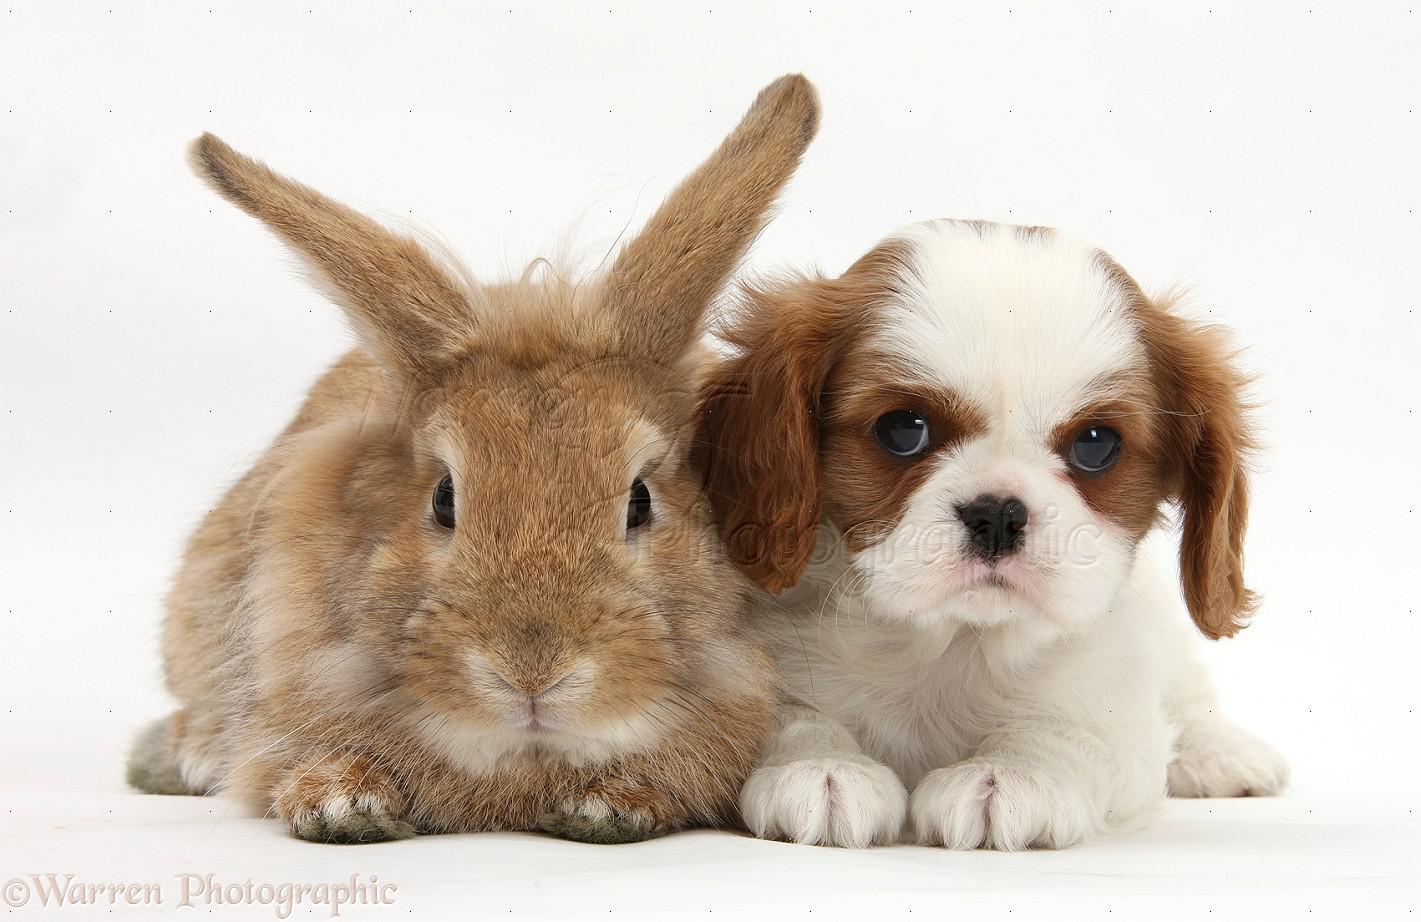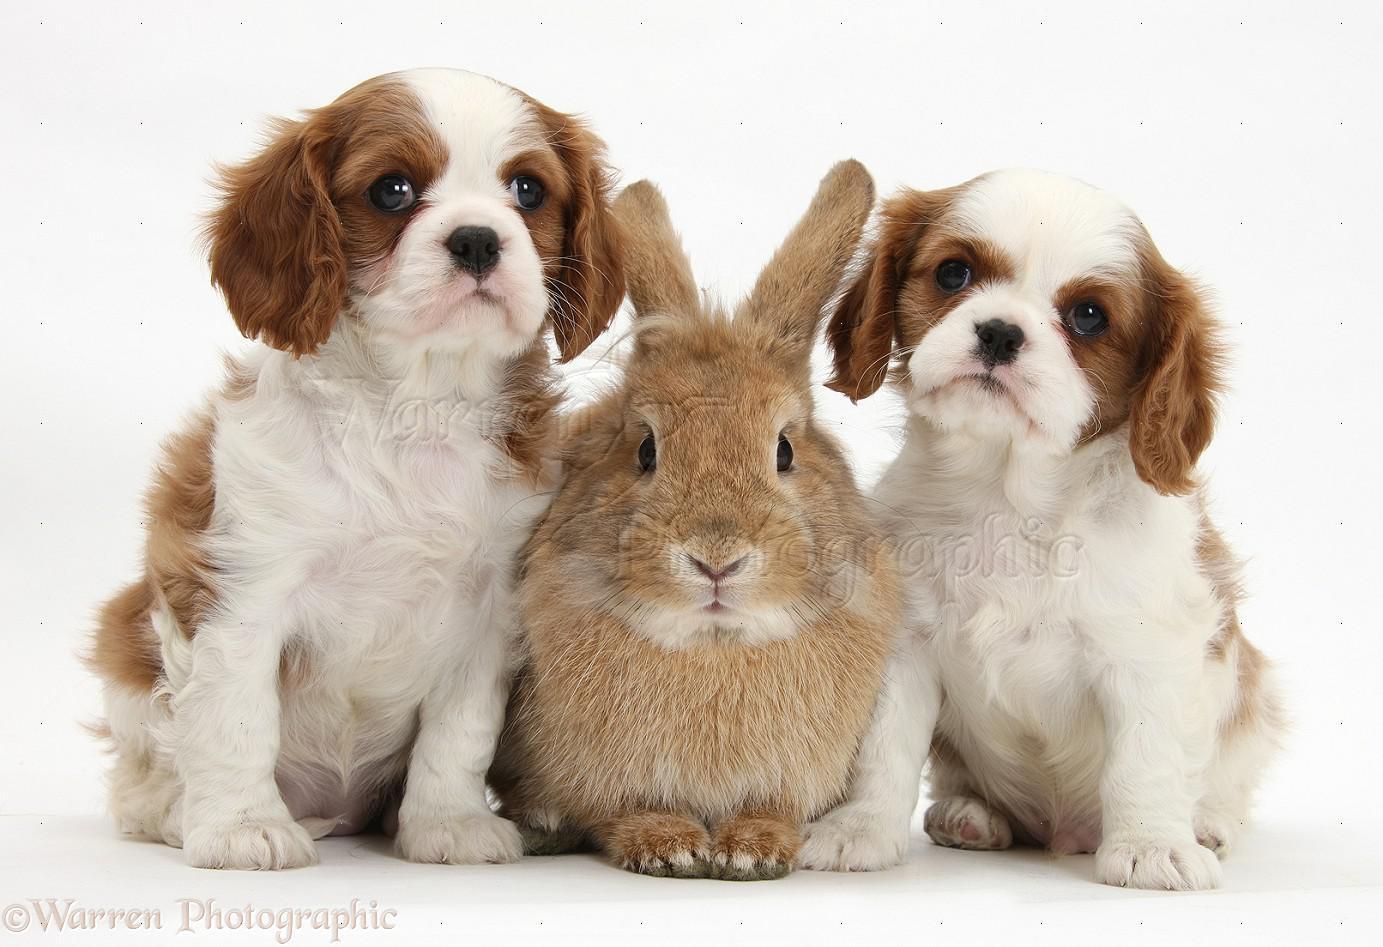The first image is the image on the left, the second image is the image on the right. Considering the images on both sides, is "A rabbit is between two puppies in one image." valid? Answer yes or no. Yes. The first image is the image on the left, the second image is the image on the right. Evaluate the accuracy of this statement regarding the images: "In one of the images, a brown rabbit is in between two white and brown cocker spaniel puppies". Is it true? Answer yes or no. Yes. 